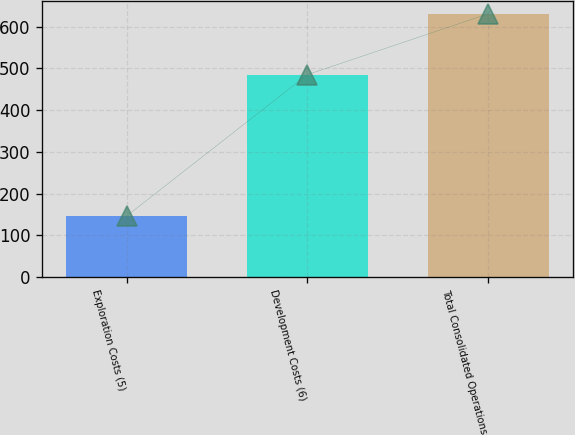<chart> <loc_0><loc_0><loc_500><loc_500><bar_chart><fcel>Exploration Costs (5)<fcel>Development Costs (6)<fcel>Total Consolidated Operations<nl><fcel>146<fcel>485<fcel>631<nl></chart> 